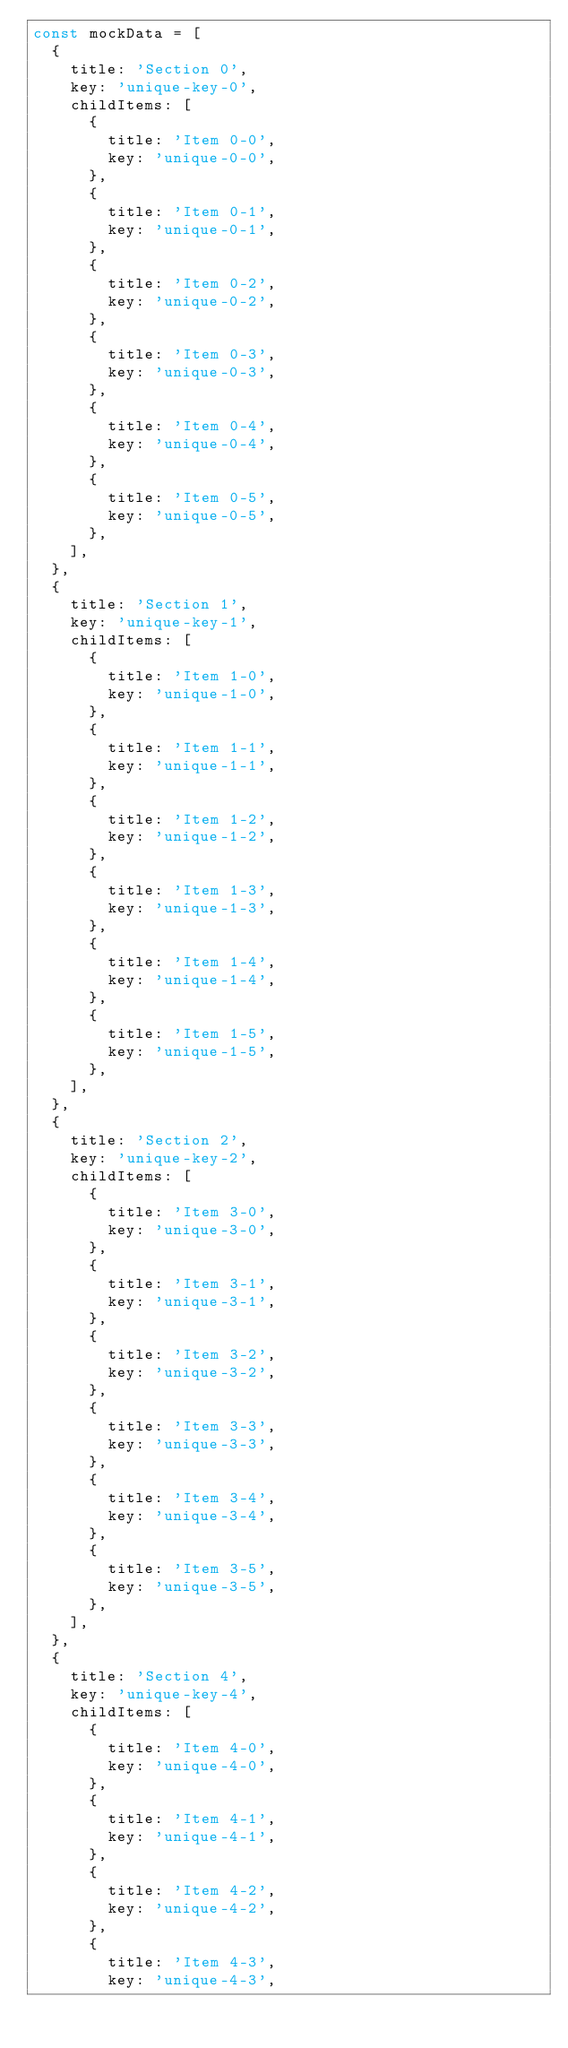<code> <loc_0><loc_0><loc_500><loc_500><_JavaScript_>const mockData = [
  {
    title: 'Section 0',
    key: 'unique-key-0',
    childItems: [
      {
        title: 'Item 0-0',
        key: 'unique-0-0',
      },
      {
        title: 'Item 0-1',
        key: 'unique-0-1',
      },
      {
        title: 'Item 0-2',
        key: 'unique-0-2',
      },
      {
        title: 'Item 0-3',
        key: 'unique-0-3',
      },
      {
        title: 'Item 0-4',
        key: 'unique-0-4',
      },
      {
        title: 'Item 0-5',
        key: 'unique-0-5',
      },
    ],
  },
  {
    title: 'Section 1',
    key: 'unique-key-1',
    childItems: [
      {
        title: 'Item 1-0',
        key: 'unique-1-0',
      },
      {
        title: 'Item 1-1',
        key: 'unique-1-1',
      },
      {
        title: 'Item 1-2',
        key: 'unique-1-2',
      },
      {
        title: 'Item 1-3',
        key: 'unique-1-3',
      },
      {
        title: 'Item 1-4',
        key: 'unique-1-4',
      },
      {
        title: 'Item 1-5',
        key: 'unique-1-5',
      },
    ],
  },
  {
    title: 'Section 2',
    key: 'unique-key-2',
    childItems: [
      {
        title: 'Item 3-0',
        key: 'unique-3-0',
      },
      {
        title: 'Item 3-1',
        key: 'unique-3-1',
      },
      {
        title: 'Item 3-2',
        key: 'unique-3-2',
      },
      {
        title: 'Item 3-3',
        key: 'unique-3-3',
      },
      {
        title: 'Item 3-4',
        key: 'unique-3-4',
      },
      {
        title: 'Item 3-5',
        key: 'unique-3-5',
      },
    ],
  },
  {
    title: 'Section 4',
    key: 'unique-key-4',
    childItems: [
      {
        title: 'Item 4-0',
        key: 'unique-4-0',
      },
      {
        title: 'Item 4-1',
        key: 'unique-4-1',
      },
      {
        title: 'Item 4-2',
        key: 'unique-4-2',
      },
      {
        title: 'Item 4-3',
        key: 'unique-4-3',</code> 